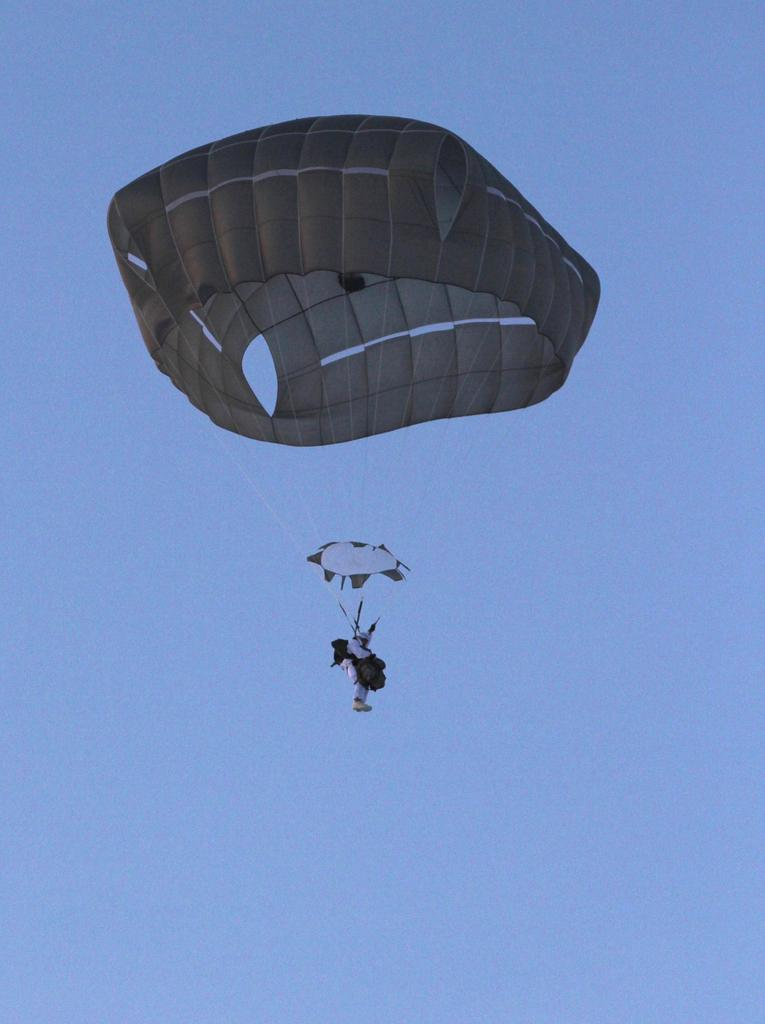What is the main subject of the image? There is a person in the image. What is the person doing in the image? The person is flying with a parachute. What can be seen in the background of the image? The sky is visible at the top of the image. What type of sponge can be seen floating in the sky in the image? There is no sponge present in the image; the person is flying with a parachute in the sky. 